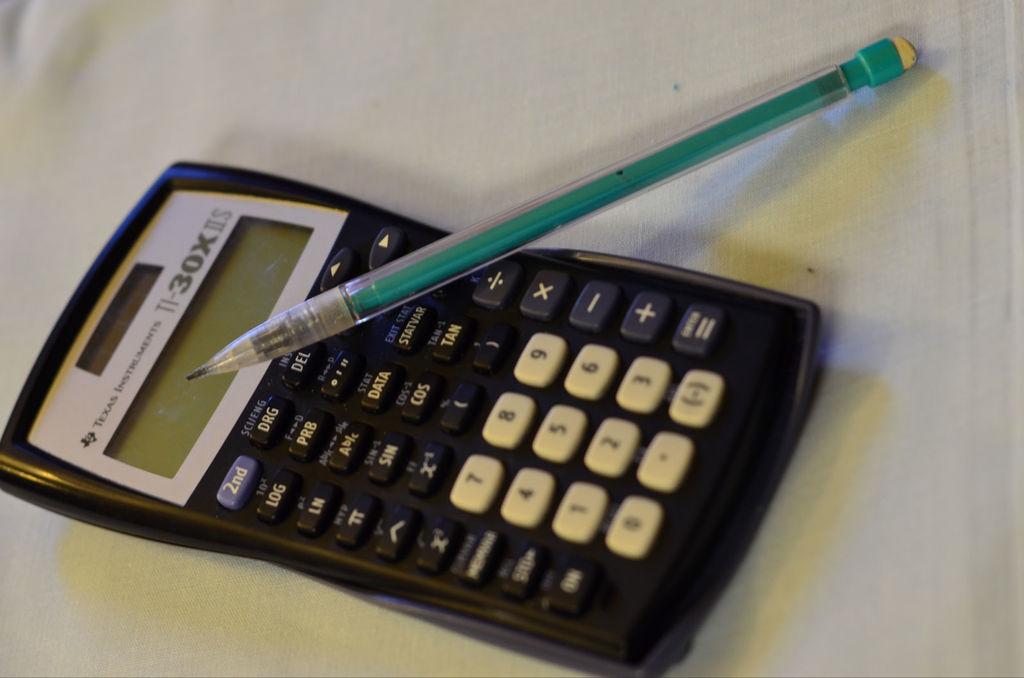What state is mentioned at the top of the calculator?
Provide a succinct answer. Texas. Is this a ti-31x? or 30x?
Your answer should be compact. 30x. 